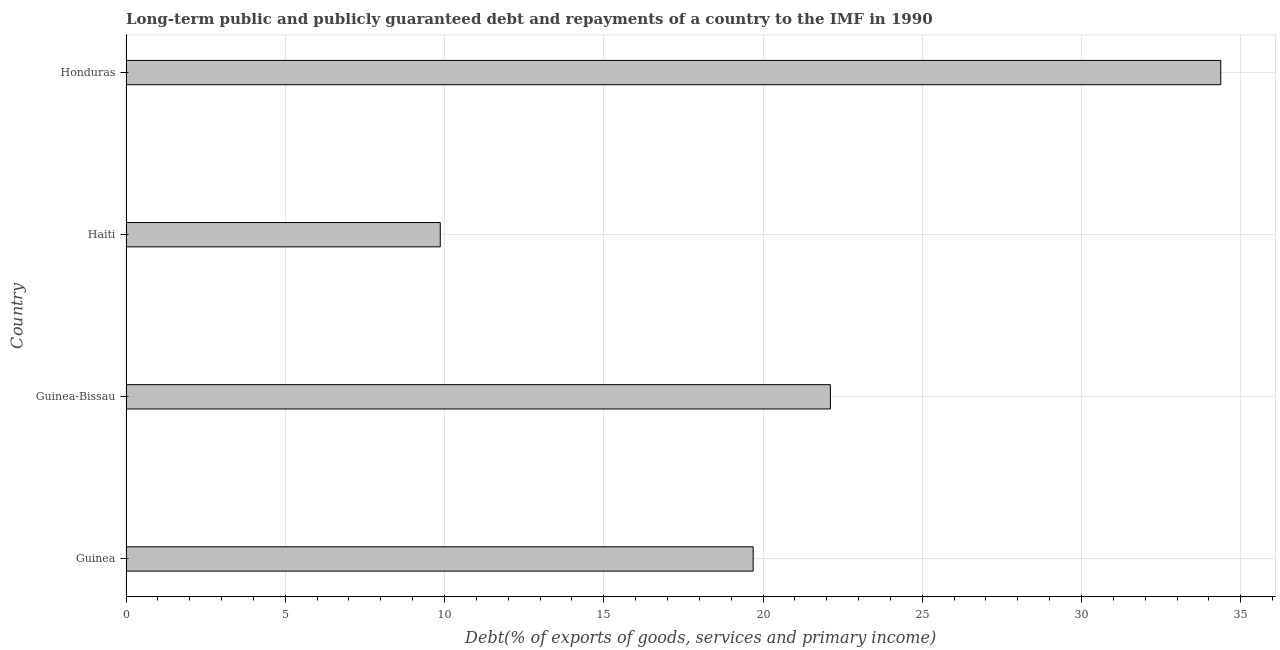What is the title of the graph?
Provide a short and direct response. Long-term public and publicly guaranteed debt and repayments of a country to the IMF in 1990. What is the label or title of the X-axis?
Offer a terse response. Debt(% of exports of goods, services and primary income). What is the debt service in Guinea-Bissau?
Make the answer very short. 22.11. Across all countries, what is the maximum debt service?
Your response must be concise. 34.37. Across all countries, what is the minimum debt service?
Your answer should be compact. 9.87. In which country was the debt service maximum?
Ensure brevity in your answer.  Honduras. In which country was the debt service minimum?
Offer a very short reply. Haiti. What is the sum of the debt service?
Provide a short and direct response. 86.04. What is the difference between the debt service in Guinea-Bissau and Haiti?
Keep it short and to the point. 12.25. What is the average debt service per country?
Give a very brief answer. 21.51. What is the median debt service?
Make the answer very short. 20.9. In how many countries, is the debt service greater than 18 %?
Keep it short and to the point. 3. What is the ratio of the debt service in Haiti to that in Honduras?
Provide a short and direct response. 0.29. Is the debt service in Guinea less than that in Haiti?
Give a very brief answer. No. Is the difference between the debt service in Guinea and Haiti greater than the difference between any two countries?
Your answer should be very brief. No. What is the difference between the highest and the second highest debt service?
Offer a very short reply. 12.26. Is the sum of the debt service in Guinea and Guinea-Bissau greater than the maximum debt service across all countries?
Make the answer very short. Yes. How many bars are there?
Provide a short and direct response. 4. How many countries are there in the graph?
Your answer should be compact. 4. What is the Debt(% of exports of goods, services and primary income) of Guinea?
Offer a very short reply. 19.69. What is the Debt(% of exports of goods, services and primary income) in Guinea-Bissau?
Offer a very short reply. 22.11. What is the Debt(% of exports of goods, services and primary income) of Haiti?
Your answer should be very brief. 9.87. What is the Debt(% of exports of goods, services and primary income) of Honduras?
Provide a succinct answer. 34.37. What is the difference between the Debt(% of exports of goods, services and primary income) in Guinea and Guinea-Bissau?
Your response must be concise. -2.42. What is the difference between the Debt(% of exports of goods, services and primary income) in Guinea and Haiti?
Give a very brief answer. 9.82. What is the difference between the Debt(% of exports of goods, services and primary income) in Guinea and Honduras?
Your answer should be very brief. -14.68. What is the difference between the Debt(% of exports of goods, services and primary income) in Guinea-Bissau and Haiti?
Make the answer very short. 12.25. What is the difference between the Debt(% of exports of goods, services and primary income) in Guinea-Bissau and Honduras?
Provide a succinct answer. -12.26. What is the difference between the Debt(% of exports of goods, services and primary income) in Haiti and Honduras?
Make the answer very short. -24.5. What is the ratio of the Debt(% of exports of goods, services and primary income) in Guinea to that in Guinea-Bissau?
Offer a very short reply. 0.89. What is the ratio of the Debt(% of exports of goods, services and primary income) in Guinea to that in Haiti?
Give a very brief answer. 2. What is the ratio of the Debt(% of exports of goods, services and primary income) in Guinea to that in Honduras?
Provide a succinct answer. 0.57. What is the ratio of the Debt(% of exports of goods, services and primary income) in Guinea-Bissau to that in Haiti?
Your answer should be very brief. 2.24. What is the ratio of the Debt(% of exports of goods, services and primary income) in Guinea-Bissau to that in Honduras?
Your answer should be very brief. 0.64. What is the ratio of the Debt(% of exports of goods, services and primary income) in Haiti to that in Honduras?
Your answer should be compact. 0.29. 